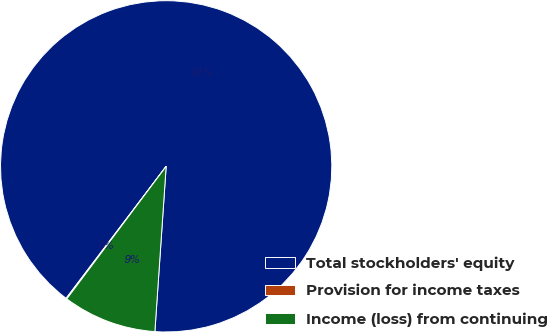<chart> <loc_0><loc_0><loc_500><loc_500><pie_chart><fcel>Total stockholders' equity<fcel>Provision for income taxes<fcel>Income (loss) from continuing<nl><fcel>90.76%<fcel>0.09%<fcel>9.15%<nl></chart> 